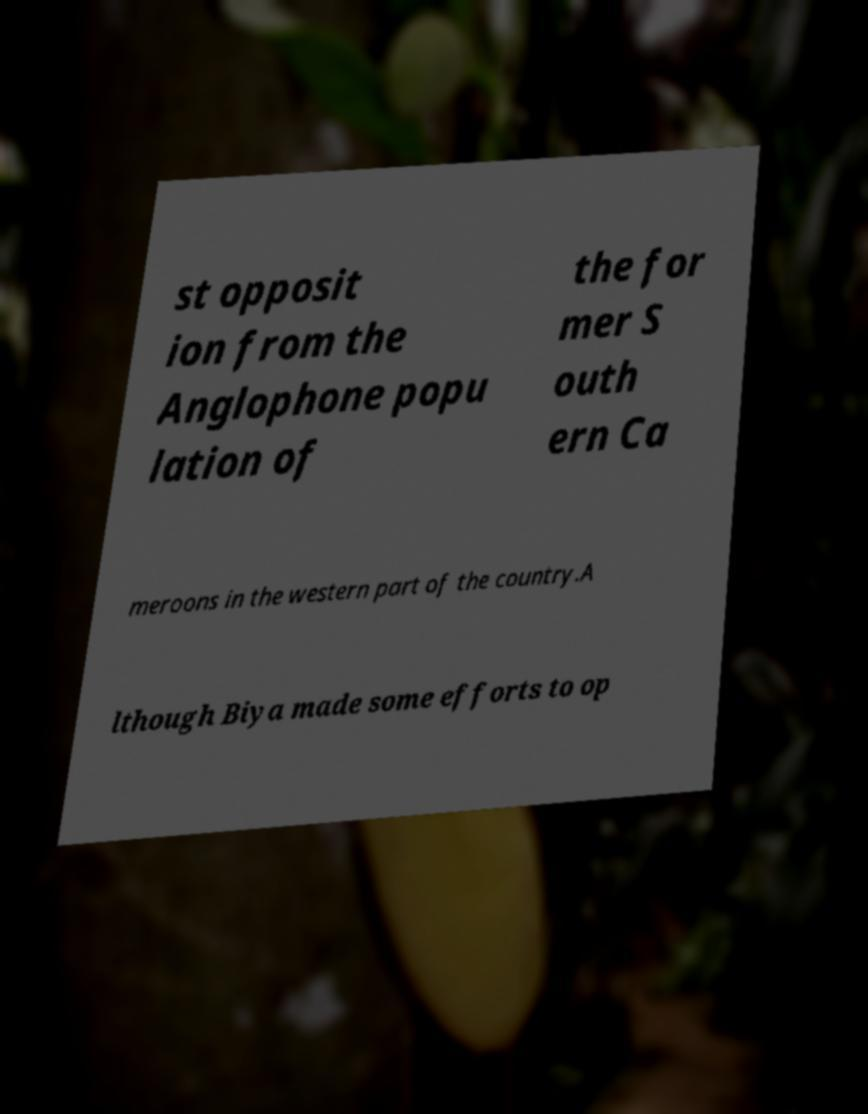There's text embedded in this image that I need extracted. Can you transcribe it verbatim? st opposit ion from the Anglophone popu lation of the for mer S outh ern Ca meroons in the western part of the country.A lthough Biya made some efforts to op 